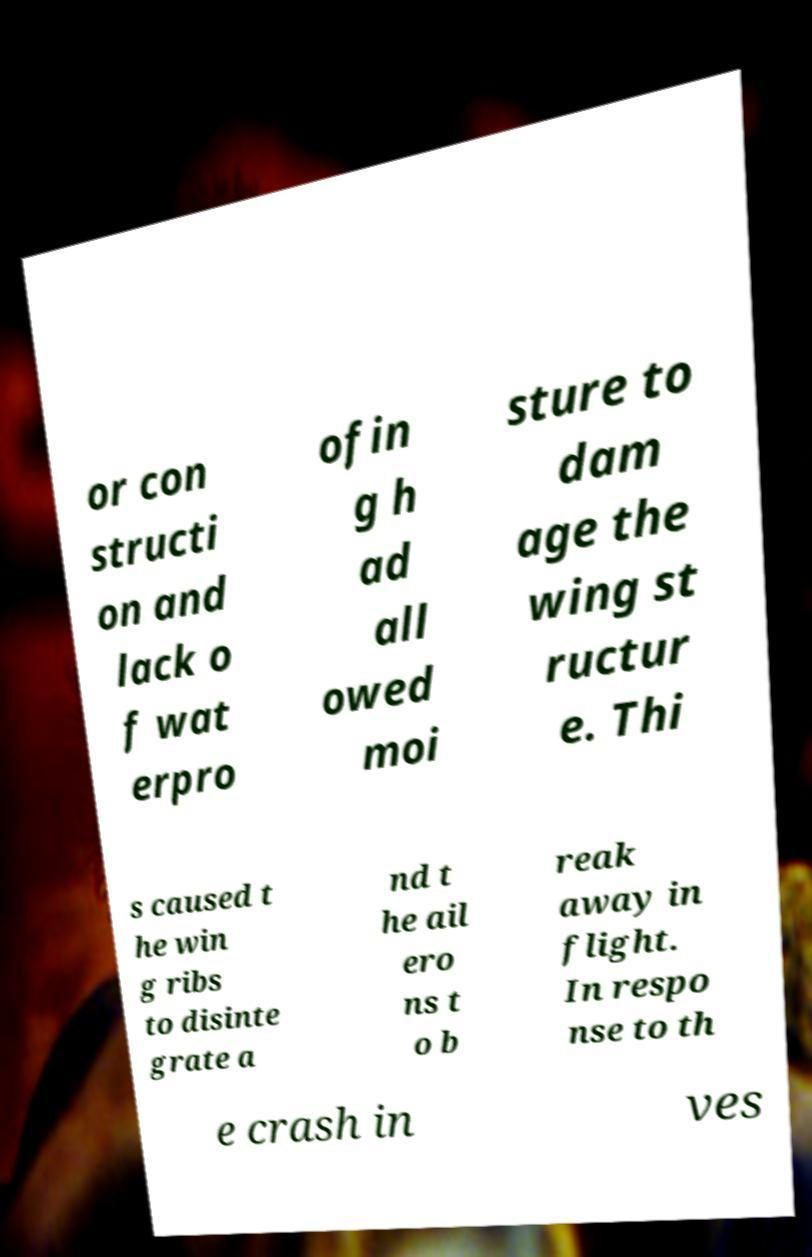I need the written content from this picture converted into text. Can you do that? or con structi on and lack o f wat erpro ofin g h ad all owed moi sture to dam age the wing st ructur e. Thi s caused t he win g ribs to disinte grate a nd t he ail ero ns t o b reak away in flight. In respo nse to th e crash in ves 